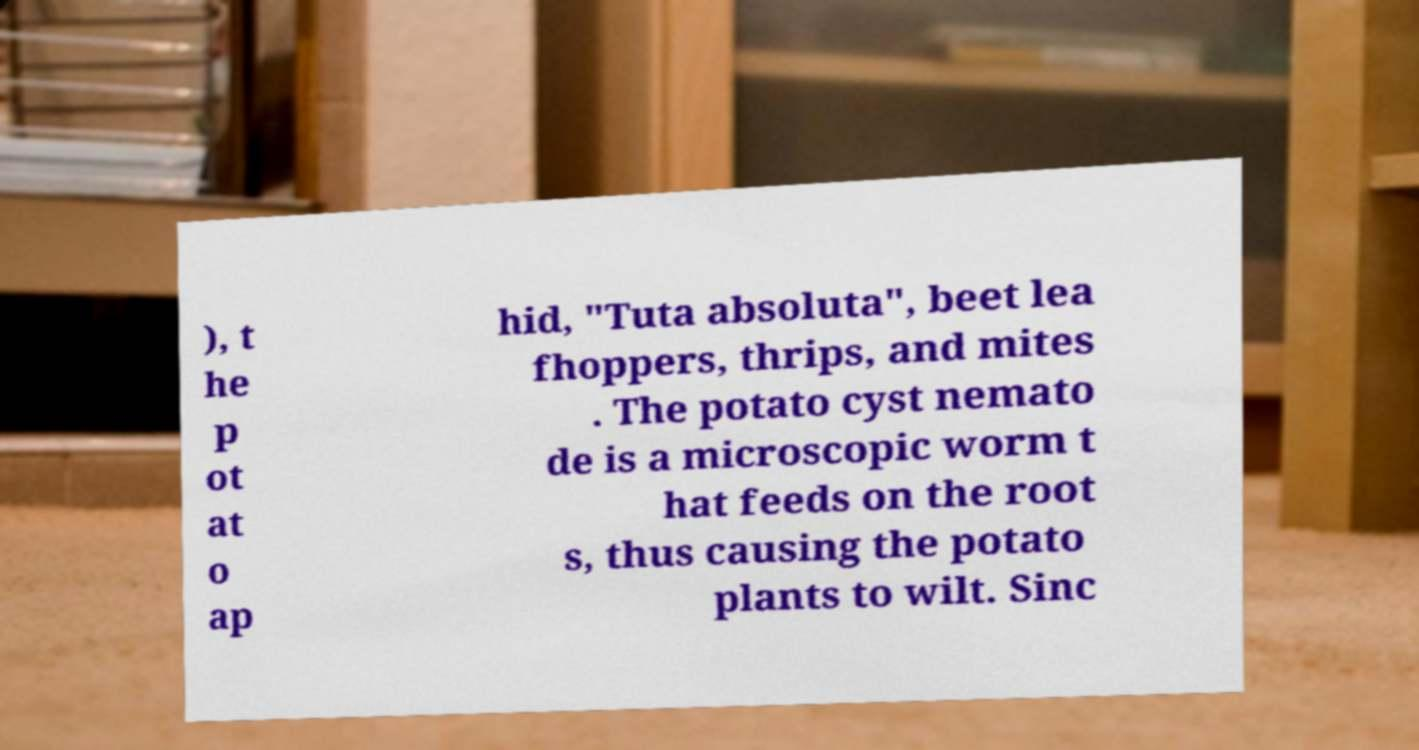Could you assist in decoding the text presented in this image and type it out clearly? ), t he p ot at o ap hid, "Tuta absoluta", beet lea fhoppers, thrips, and mites . The potato cyst nemato de is a microscopic worm t hat feeds on the root s, thus causing the potato plants to wilt. Sinc 